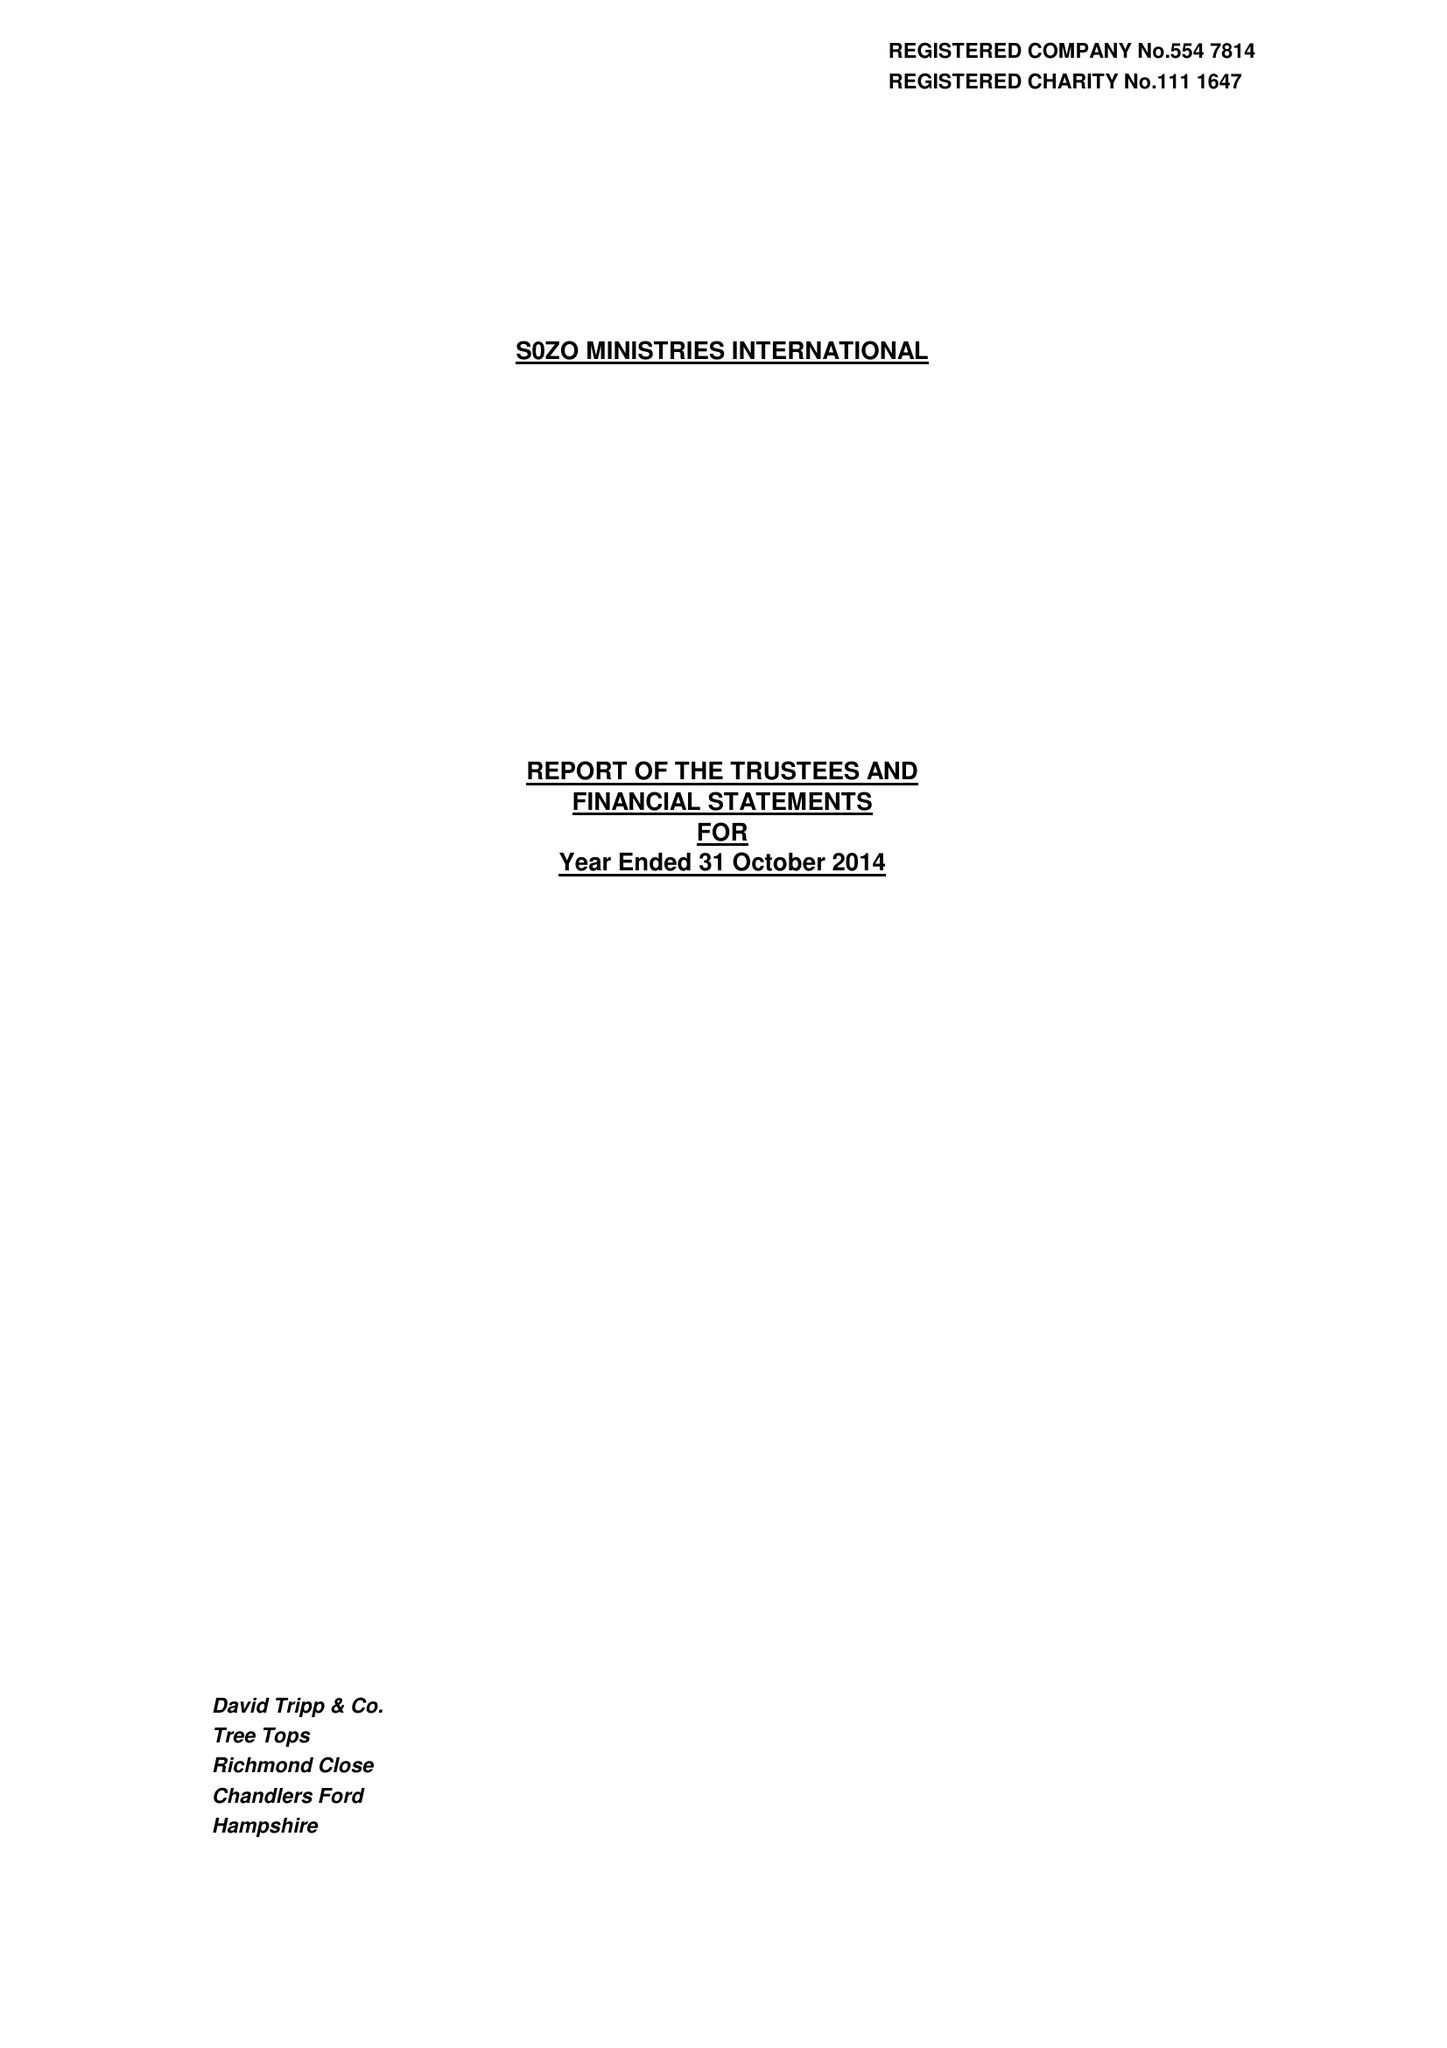What is the value for the spending_annually_in_british_pounds?
Answer the question using a single word or phrase. 349603.00 